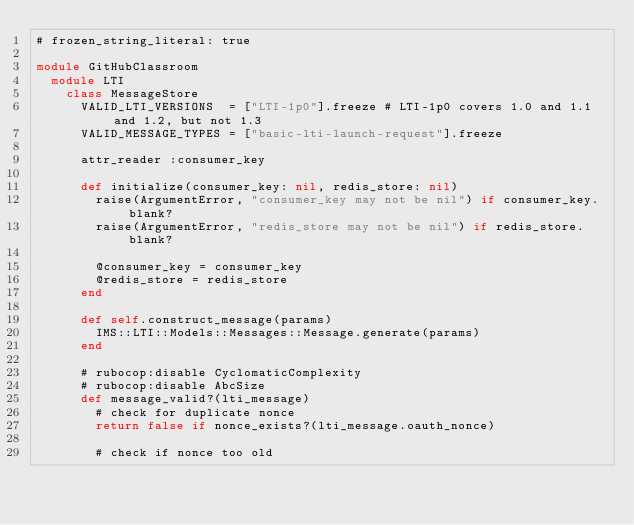<code> <loc_0><loc_0><loc_500><loc_500><_Ruby_># frozen_string_literal: true

module GitHubClassroom
  module LTI
    class MessageStore
      VALID_LTI_VERSIONS  = ["LTI-1p0"].freeze # LTI-1p0 covers 1.0 and 1.1 and 1.2, but not 1.3
      VALID_MESSAGE_TYPES = ["basic-lti-launch-request"].freeze

      attr_reader :consumer_key

      def initialize(consumer_key: nil, redis_store: nil)
        raise(ArgumentError, "consumer_key may not be nil") if consumer_key.blank?
        raise(ArgumentError, "redis_store may not be nil") if redis_store.blank?

        @consumer_key = consumer_key
        @redis_store = redis_store
      end

      def self.construct_message(params)
        IMS::LTI::Models::Messages::Message.generate(params)
      end

      # rubocop:disable CyclomaticComplexity
      # rubocop:disable AbcSize
      def message_valid?(lti_message)
        # check for duplicate nonce
        return false if nonce_exists?(lti_message.oauth_nonce)

        # check if nonce too old</code> 